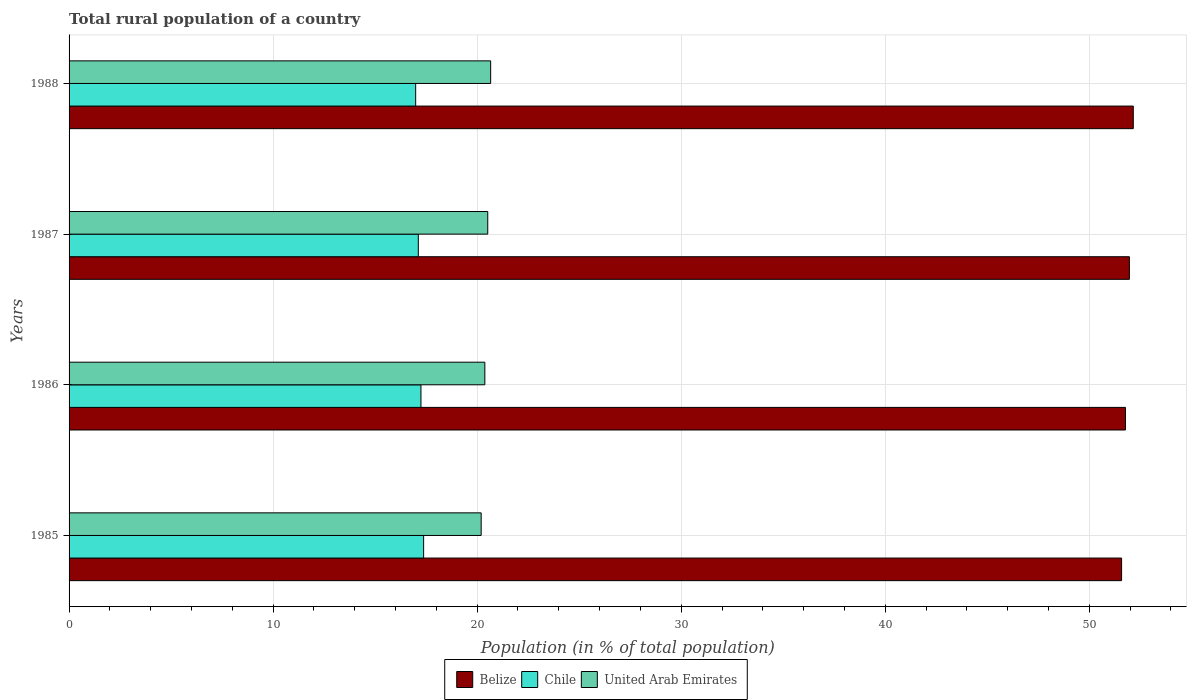How many bars are there on the 2nd tick from the top?
Your response must be concise. 3. In how many cases, is the number of bars for a given year not equal to the number of legend labels?
Offer a terse response. 0. What is the rural population in Belize in 1987?
Offer a terse response. 51.96. Across all years, what is the maximum rural population in United Arab Emirates?
Offer a terse response. 20.66. Across all years, what is the minimum rural population in Chile?
Give a very brief answer. 16.99. In which year was the rural population in United Arab Emirates maximum?
Your answer should be compact. 1988. In which year was the rural population in United Arab Emirates minimum?
Your response must be concise. 1985. What is the total rural population in United Arab Emirates in the graph?
Offer a terse response. 81.75. What is the difference between the rural population in Chile in 1985 and that in 1987?
Provide a short and direct response. 0.26. What is the difference between the rural population in Chile in 1987 and the rural population in United Arab Emirates in 1986?
Your answer should be very brief. -3.26. What is the average rural population in Chile per year?
Keep it short and to the point. 17.18. In the year 1986, what is the difference between the rural population in United Arab Emirates and rural population in Chile?
Keep it short and to the point. 3.13. In how many years, is the rural population in United Arab Emirates greater than 24 %?
Offer a very short reply. 0. What is the ratio of the rural population in United Arab Emirates in 1986 to that in 1987?
Offer a very short reply. 0.99. Is the rural population in Belize in 1986 less than that in 1988?
Your answer should be very brief. Yes. What is the difference between the highest and the second highest rural population in United Arab Emirates?
Offer a very short reply. 0.14. What is the difference between the highest and the lowest rural population in Chile?
Provide a succinct answer. 0.39. In how many years, is the rural population in United Arab Emirates greater than the average rural population in United Arab Emirates taken over all years?
Provide a succinct answer. 2. Is the sum of the rural population in Chile in 1986 and 1988 greater than the maximum rural population in United Arab Emirates across all years?
Keep it short and to the point. Yes. What does the 1st bar from the top in 1986 represents?
Keep it short and to the point. United Arab Emirates. What does the 1st bar from the bottom in 1987 represents?
Provide a succinct answer. Belize. Is it the case that in every year, the sum of the rural population in Belize and rural population in Chile is greater than the rural population in United Arab Emirates?
Your answer should be compact. Yes. How many bars are there?
Provide a succinct answer. 12. Are all the bars in the graph horizontal?
Your answer should be compact. Yes. What is the difference between two consecutive major ticks on the X-axis?
Offer a very short reply. 10. Does the graph contain any zero values?
Provide a succinct answer. No. How many legend labels are there?
Make the answer very short. 3. What is the title of the graph?
Ensure brevity in your answer.  Total rural population of a country. What is the label or title of the X-axis?
Provide a succinct answer. Population (in % of total population). What is the Population (in % of total population) in Belize in 1985?
Provide a short and direct response. 51.58. What is the Population (in % of total population) in Chile in 1985?
Give a very brief answer. 17.38. What is the Population (in % of total population) of United Arab Emirates in 1985?
Your response must be concise. 20.2. What is the Population (in % of total population) in Belize in 1986?
Make the answer very short. 51.77. What is the Population (in % of total population) of Chile in 1986?
Provide a succinct answer. 17.25. What is the Population (in % of total population) in United Arab Emirates in 1986?
Provide a short and direct response. 20.38. What is the Population (in % of total population) in Belize in 1987?
Ensure brevity in your answer.  51.96. What is the Population (in % of total population) in Chile in 1987?
Provide a short and direct response. 17.11. What is the Population (in % of total population) of United Arab Emirates in 1987?
Your answer should be compact. 20.52. What is the Population (in % of total population) of Belize in 1988?
Ensure brevity in your answer.  52.15. What is the Population (in % of total population) in Chile in 1988?
Provide a short and direct response. 16.99. What is the Population (in % of total population) in United Arab Emirates in 1988?
Ensure brevity in your answer.  20.66. Across all years, what is the maximum Population (in % of total population) of Belize?
Make the answer very short. 52.15. Across all years, what is the maximum Population (in % of total population) in Chile?
Give a very brief answer. 17.38. Across all years, what is the maximum Population (in % of total population) of United Arab Emirates?
Provide a short and direct response. 20.66. Across all years, what is the minimum Population (in % of total population) in Belize?
Ensure brevity in your answer.  51.58. Across all years, what is the minimum Population (in % of total population) in Chile?
Provide a succinct answer. 16.99. Across all years, what is the minimum Population (in % of total population) in United Arab Emirates?
Keep it short and to the point. 20.2. What is the total Population (in % of total population) of Belize in the graph?
Your answer should be compact. 207.47. What is the total Population (in % of total population) in Chile in the graph?
Ensure brevity in your answer.  68.72. What is the total Population (in % of total population) in United Arab Emirates in the graph?
Your response must be concise. 81.75. What is the difference between the Population (in % of total population) in Belize in 1985 and that in 1986?
Make the answer very short. -0.19. What is the difference between the Population (in % of total population) of Chile in 1985 and that in 1986?
Offer a very short reply. 0.13. What is the difference between the Population (in % of total population) of United Arab Emirates in 1985 and that in 1986?
Give a very brief answer. -0.18. What is the difference between the Population (in % of total population) in Belize in 1985 and that in 1987?
Your answer should be very brief. -0.38. What is the difference between the Population (in % of total population) of Chile in 1985 and that in 1987?
Provide a succinct answer. 0.26. What is the difference between the Population (in % of total population) of United Arab Emirates in 1985 and that in 1987?
Make the answer very short. -0.32. What is the difference between the Population (in % of total population) of Belize in 1985 and that in 1988?
Provide a succinct answer. -0.57. What is the difference between the Population (in % of total population) of Chile in 1985 and that in 1988?
Your answer should be compact. 0.39. What is the difference between the Population (in % of total population) of United Arab Emirates in 1985 and that in 1988?
Give a very brief answer. -0.47. What is the difference between the Population (in % of total population) in Belize in 1986 and that in 1987?
Your response must be concise. -0.19. What is the difference between the Population (in % of total population) in Chile in 1986 and that in 1987?
Provide a succinct answer. 0.13. What is the difference between the Population (in % of total population) in United Arab Emirates in 1986 and that in 1987?
Provide a succinct answer. -0.14. What is the difference between the Population (in % of total population) in Belize in 1986 and that in 1988?
Provide a short and direct response. -0.38. What is the difference between the Population (in % of total population) in Chile in 1986 and that in 1988?
Keep it short and to the point. 0.26. What is the difference between the Population (in % of total population) in United Arab Emirates in 1986 and that in 1988?
Give a very brief answer. -0.28. What is the difference between the Population (in % of total population) of Belize in 1987 and that in 1988?
Make the answer very short. -0.19. What is the difference between the Population (in % of total population) of Chile in 1987 and that in 1988?
Provide a short and direct response. 0.13. What is the difference between the Population (in % of total population) in United Arab Emirates in 1987 and that in 1988?
Give a very brief answer. -0.14. What is the difference between the Population (in % of total population) in Belize in 1985 and the Population (in % of total population) in Chile in 1986?
Ensure brevity in your answer.  34.34. What is the difference between the Population (in % of total population) of Belize in 1985 and the Population (in % of total population) of United Arab Emirates in 1986?
Provide a succinct answer. 31.2. What is the difference between the Population (in % of total population) of Chile in 1985 and the Population (in % of total population) of United Arab Emirates in 1986?
Provide a succinct answer. -3. What is the difference between the Population (in % of total population) in Belize in 1985 and the Population (in % of total population) in Chile in 1987?
Give a very brief answer. 34.47. What is the difference between the Population (in % of total population) of Belize in 1985 and the Population (in % of total population) of United Arab Emirates in 1987?
Your response must be concise. 31.06. What is the difference between the Population (in % of total population) of Chile in 1985 and the Population (in % of total population) of United Arab Emirates in 1987?
Offer a very short reply. -3.14. What is the difference between the Population (in % of total population) of Belize in 1985 and the Population (in % of total population) of Chile in 1988?
Ensure brevity in your answer.  34.59. What is the difference between the Population (in % of total population) in Belize in 1985 and the Population (in % of total population) in United Arab Emirates in 1988?
Offer a very short reply. 30.92. What is the difference between the Population (in % of total population) of Chile in 1985 and the Population (in % of total population) of United Arab Emirates in 1988?
Offer a terse response. -3.29. What is the difference between the Population (in % of total population) of Belize in 1986 and the Population (in % of total population) of Chile in 1987?
Offer a terse response. 34.66. What is the difference between the Population (in % of total population) in Belize in 1986 and the Population (in % of total population) in United Arab Emirates in 1987?
Keep it short and to the point. 31.25. What is the difference between the Population (in % of total population) in Chile in 1986 and the Population (in % of total population) in United Arab Emirates in 1987?
Your answer should be compact. -3.27. What is the difference between the Population (in % of total population) of Belize in 1986 and the Population (in % of total population) of Chile in 1988?
Keep it short and to the point. 34.79. What is the difference between the Population (in % of total population) of Belize in 1986 and the Population (in % of total population) of United Arab Emirates in 1988?
Make the answer very short. 31.11. What is the difference between the Population (in % of total population) in Chile in 1986 and the Population (in % of total population) in United Arab Emirates in 1988?
Your answer should be compact. -3.42. What is the difference between the Population (in % of total population) of Belize in 1987 and the Population (in % of total population) of Chile in 1988?
Your response must be concise. 34.98. What is the difference between the Population (in % of total population) of Belize in 1987 and the Population (in % of total population) of United Arab Emirates in 1988?
Your response must be concise. 31.3. What is the difference between the Population (in % of total population) of Chile in 1987 and the Population (in % of total population) of United Arab Emirates in 1988?
Provide a short and direct response. -3.55. What is the average Population (in % of total population) of Belize per year?
Offer a very short reply. 51.87. What is the average Population (in % of total population) of Chile per year?
Give a very brief answer. 17.18. What is the average Population (in % of total population) in United Arab Emirates per year?
Offer a terse response. 20.44. In the year 1985, what is the difference between the Population (in % of total population) of Belize and Population (in % of total population) of Chile?
Your response must be concise. 34.2. In the year 1985, what is the difference between the Population (in % of total population) in Belize and Population (in % of total population) in United Arab Emirates?
Provide a short and direct response. 31.39. In the year 1985, what is the difference between the Population (in % of total population) of Chile and Population (in % of total population) of United Arab Emirates?
Make the answer very short. -2.82. In the year 1986, what is the difference between the Population (in % of total population) of Belize and Population (in % of total population) of Chile?
Ensure brevity in your answer.  34.53. In the year 1986, what is the difference between the Population (in % of total population) in Belize and Population (in % of total population) in United Arab Emirates?
Your response must be concise. 31.4. In the year 1986, what is the difference between the Population (in % of total population) of Chile and Population (in % of total population) of United Arab Emirates?
Your answer should be very brief. -3.13. In the year 1987, what is the difference between the Population (in % of total population) in Belize and Population (in % of total population) in Chile?
Your answer should be compact. 34.85. In the year 1987, what is the difference between the Population (in % of total population) of Belize and Population (in % of total population) of United Arab Emirates?
Your answer should be compact. 31.45. In the year 1987, what is the difference between the Population (in % of total population) in Chile and Population (in % of total population) in United Arab Emirates?
Make the answer very short. -3.4. In the year 1988, what is the difference between the Population (in % of total population) in Belize and Population (in % of total population) in Chile?
Your answer should be very brief. 35.17. In the year 1988, what is the difference between the Population (in % of total population) in Belize and Population (in % of total population) in United Arab Emirates?
Your answer should be very brief. 31.49. In the year 1988, what is the difference between the Population (in % of total population) of Chile and Population (in % of total population) of United Arab Emirates?
Ensure brevity in your answer.  -3.67. What is the ratio of the Population (in % of total population) of Belize in 1985 to that in 1986?
Your answer should be very brief. 1. What is the ratio of the Population (in % of total population) of Chile in 1985 to that in 1986?
Make the answer very short. 1.01. What is the ratio of the Population (in % of total population) of United Arab Emirates in 1985 to that in 1986?
Provide a succinct answer. 0.99. What is the ratio of the Population (in % of total population) of Belize in 1985 to that in 1987?
Ensure brevity in your answer.  0.99. What is the ratio of the Population (in % of total population) in Chile in 1985 to that in 1987?
Provide a short and direct response. 1.02. What is the ratio of the Population (in % of total population) in United Arab Emirates in 1985 to that in 1987?
Your response must be concise. 0.98. What is the ratio of the Population (in % of total population) in Belize in 1985 to that in 1988?
Your response must be concise. 0.99. What is the ratio of the Population (in % of total population) in United Arab Emirates in 1985 to that in 1988?
Provide a short and direct response. 0.98. What is the ratio of the Population (in % of total population) of Belize in 1986 to that in 1987?
Ensure brevity in your answer.  1. What is the ratio of the Population (in % of total population) of Chile in 1986 to that in 1987?
Keep it short and to the point. 1.01. What is the ratio of the Population (in % of total population) in Belize in 1986 to that in 1988?
Make the answer very short. 0.99. What is the ratio of the Population (in % of total population) of Chile in 1986 to that in 1988?
Give a very brief answer. 1.02. What is the ratio of the Population (in % of total population) in United Arab Emirates in 1986 to that in 1988?
Make the answer very short. 0.99. What is the ratio of the Population (in % of total population) of Belize in 1987 to that in 1988?
Ensure brevity in your answer.  1. What is the ratio of the Population (in % of total population) in Chile in 1987 to that in 1988?
Offer a very short reply. 1.01. What is the difference between the highest and the second highest Population (in % of total population) in Belize?
Your response must be concise. 0.19. What is the difference between the highest and the second highest Population (in % of total population) of Chile?
Provide a succinct answer. 0.13. What is the difference between the highest and the second highest Population (in % of total population) in United Arab Emirates?
Ensure brevity in your answer.  0.14. What is the difference between the highest and the lowest Population (in % of total population) of Belize?
Your answer should be compact. 0.57. What is the difference between the highest and the lowest Population (in % of total population) in Chile?
Offer a very short reply. 0.39. What is the difference between the highest and the lowest Population (in % of total population) of United Arab Emirates?
Your answer should be compact. 0.47. 